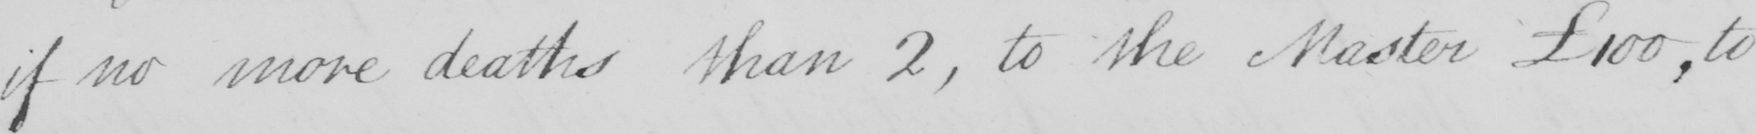Transcribe the text shown in this historical manuscript line. if no more deaths than 2 , to the Master £100  , to 